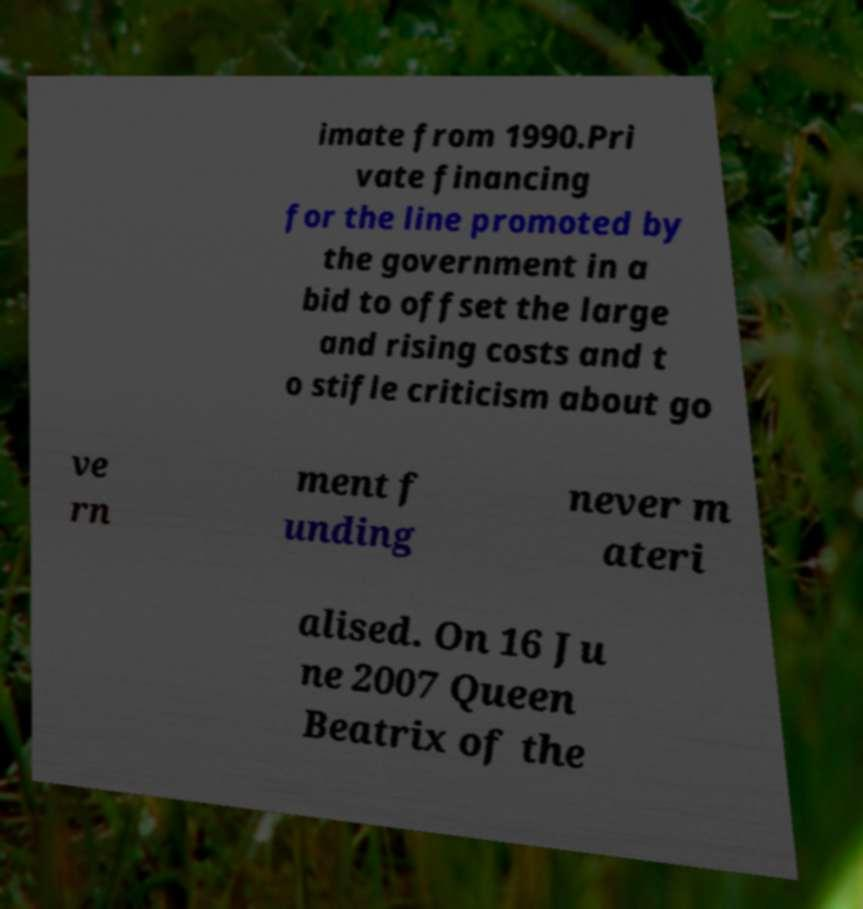What messages or text are displayed in this image? I need them in a readable, typed format. imate from 1990.Pri vate financing for the line promoted by the government in a bid to offset the large and rising costs and t o stifle criticism about go ve rn ment f unding never m ateri alised. On 16 Ju ne 2007 Queen Beatrix of the 